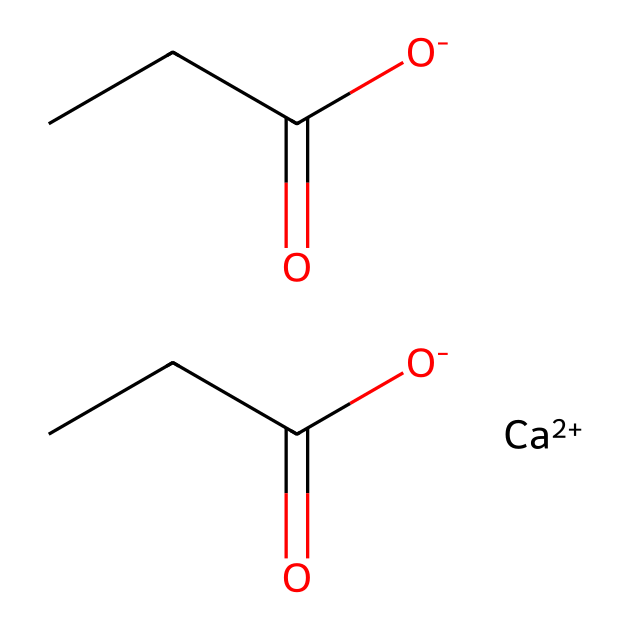What is the primary function of calcium propionate in pizza dough? Calcium propionate is used as a preservative to inhibit mold growth, thereby extending the shelf life of the pizza dough.
Answer: preservative How many carbon atoms are present in calcium propionate? By examining the structure’s carbon backbone, there are a total of 6 carbon atoms derived from the two propionate groups in the formula.
Answer: 6 What type of bonding is predominant in the calcium propionate structure? The structure features ionic bonding between calcium ions and the negatively charged propionate ions, which is typical for coordination compounds with metal ions.
Answer: ionic How many oxygen atoms are present in calcium propionate? Each propionate group contains two oxygen atoms, and with two propionate groups, there are a total of 4 oxygen atoms.
Answer: 4 What type of chemical compound is calcium propionate classified as? Calcium propionate is classified as a salt because it is formed from the neutralization of a weak acid (propionic acid) by a strong base (calcium hydroxide).
Answer: salt What does the presence of the calcium ion indicate about the solubility of calcium propionate in water? The presence of the calcium ion suggests that calcium propionate is likely soluble in water, as many calcium salts dissolve readily due to the ionic interactions with water.
Answer: soluble Is calcium propionate considered an organic or inorganic compound? Calcium propionate contains carbon and is derived from a carboxylic acid, classifying it as an organic compound.
Answer: organic 